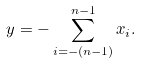<formula> <loc_0><loc_0><loc_500><loc_500>y = - \sum _ { i = - ( n - 1 ) } ^ { n - 1 } x _ { i } .</formula> 